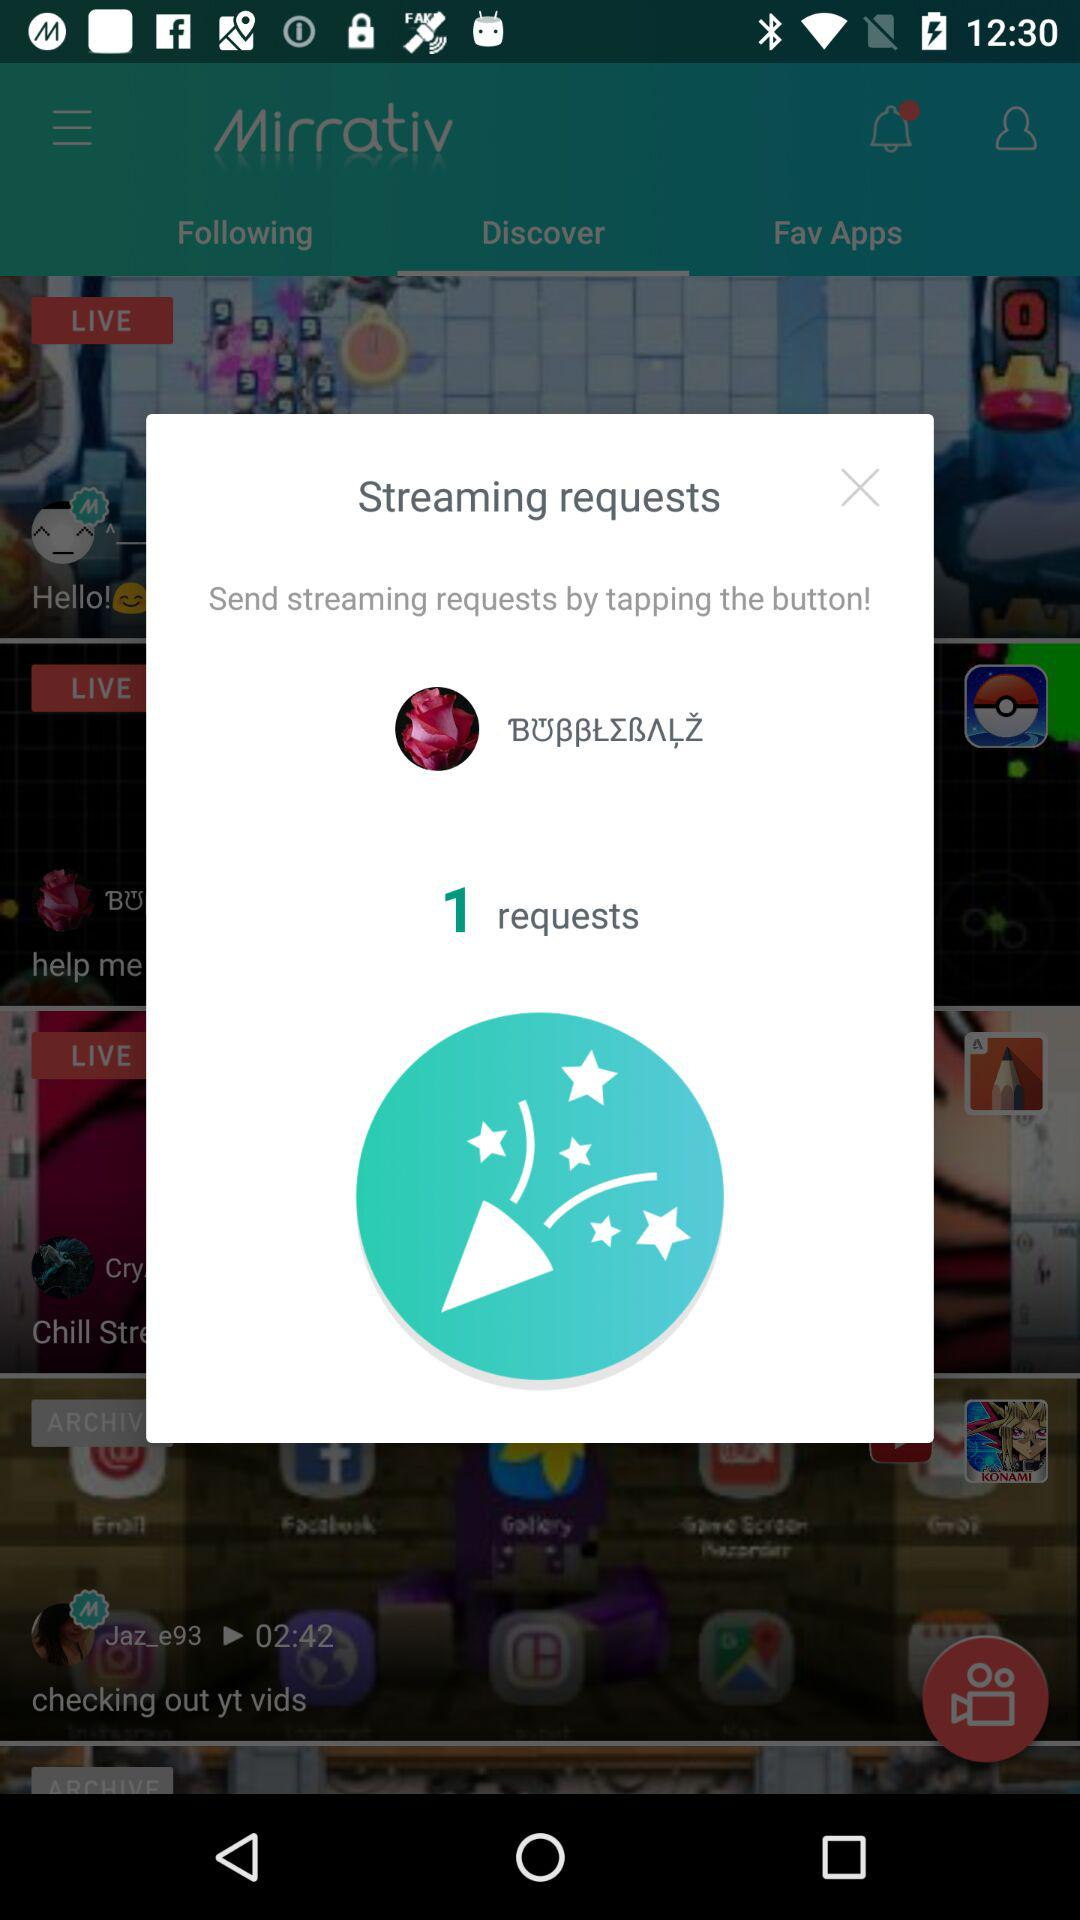How many streaming requests are there? There is 1 streaming request. 